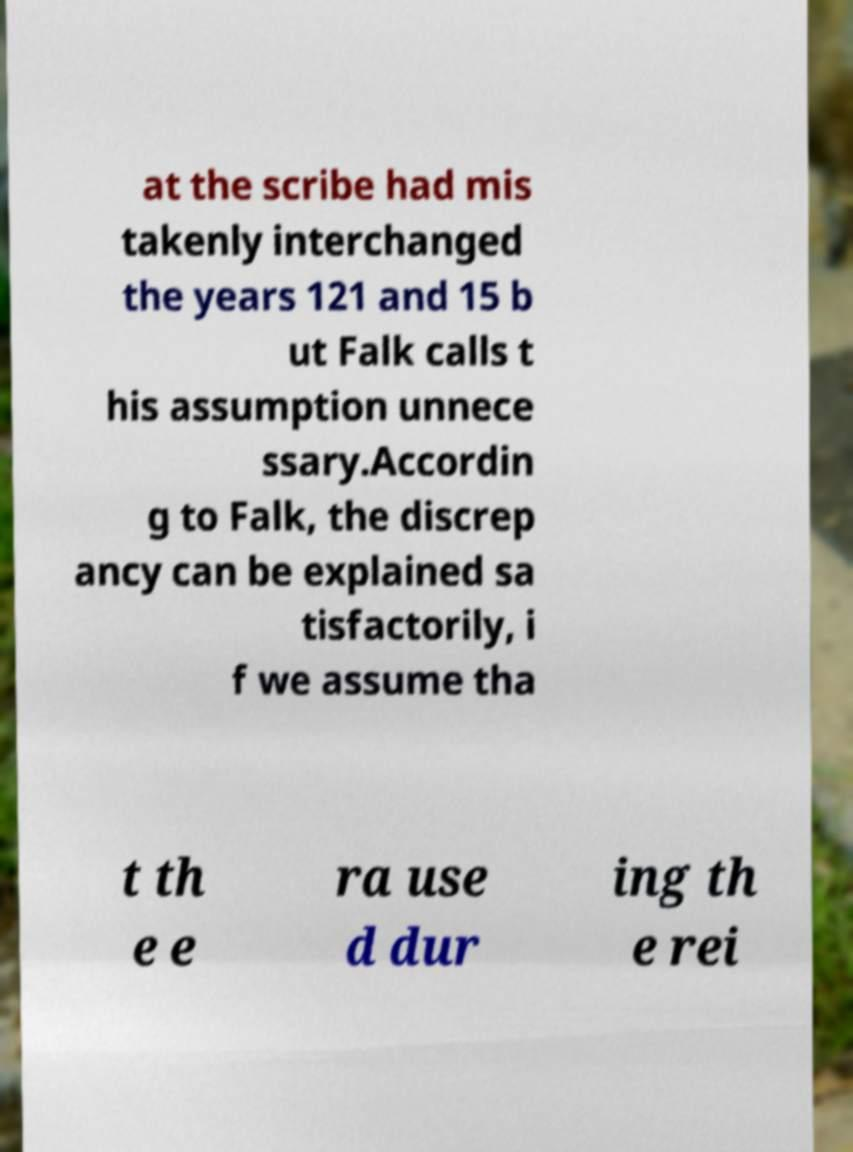Please read and relay the text visible in this image. What does it say? at the scribe had mis takenly interchanged the years 121 and 15 b ut Falk calls t his assumption unnece ssary.Accordin g to Falk, the discrep ancy can be explained sa tisfactorily, i f we assume tha t th e e ra use d dur ing th e rei 